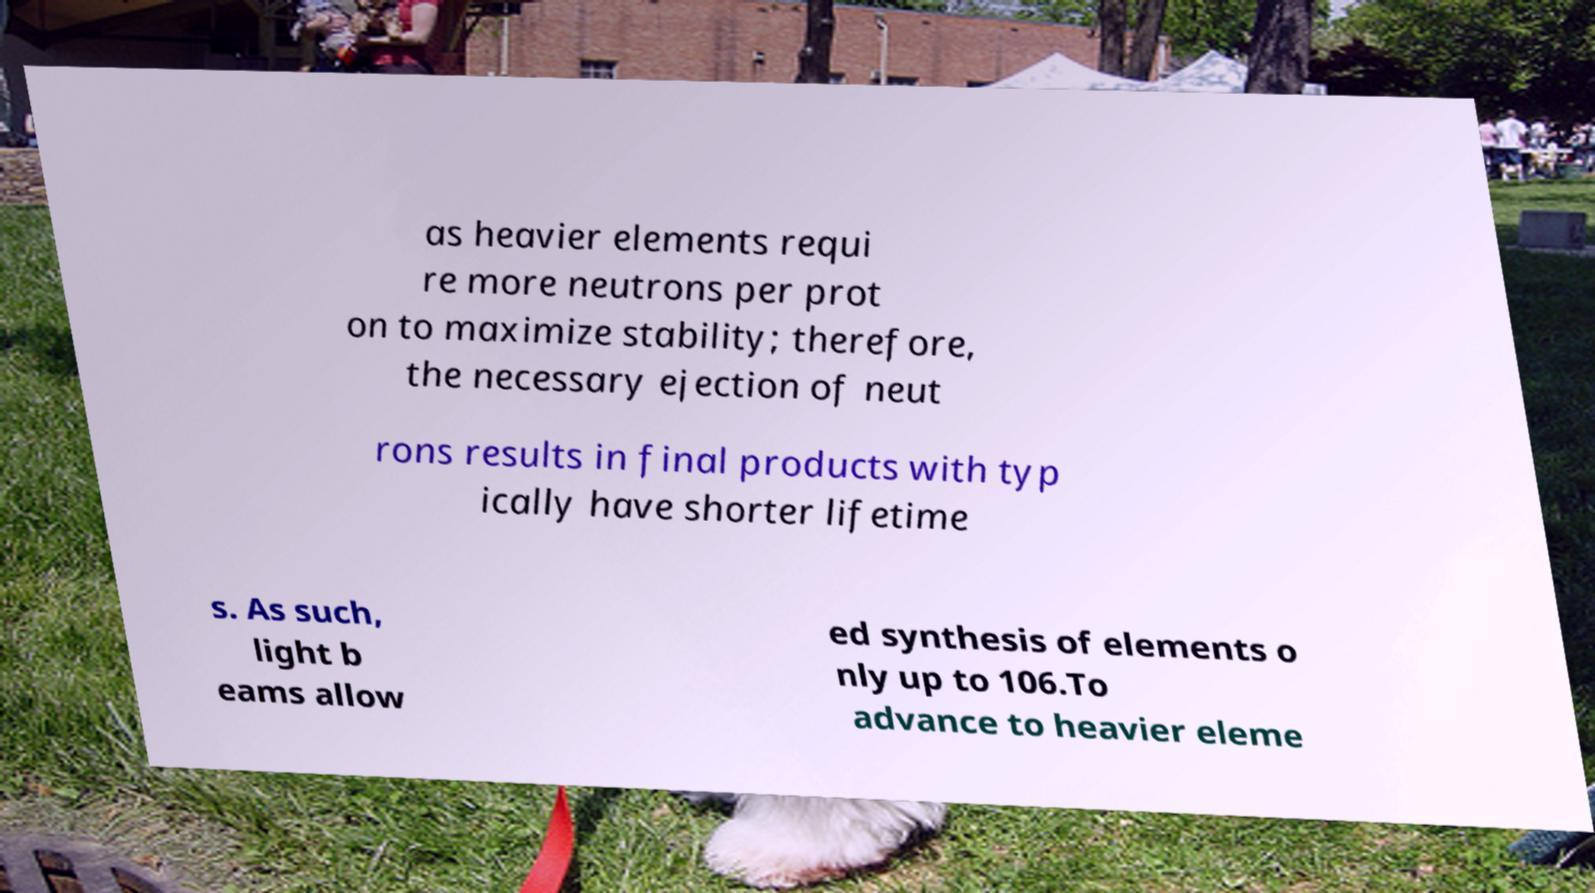For documentation purposes, I need the text within this image transcribed. Could you provide that? as heavier elements requi re more neutrons per prot on to maximize stability; therefore, the necessary ejection of neut rons results in final products with typ ically have shorter lifetime s. As such, light b eams allow ed synthesis of elements o nly up to 106.To advance to heavier eleme 